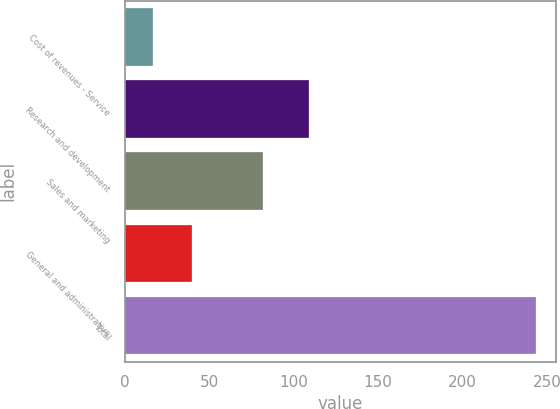Convert chart. <chart><loc_0><loc_0><loc_500><loc_500><bar_chart><fcel>Cost of revenues - Service<fcel>Research and development<fcel>Sales and marketing<fcel>General and administrative<fcel>Total<nl><fcel>17<fcel>109.1<fcel>81.6<fcel>39.64<fcel>243.4<nl></chart> 